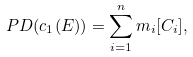<formula> <loc_0><loc_0><loc_500><loc_500>P D ( c _ { 1 } ( E ) ) = \sum _ { i = 1 } ^ { n } m _ { i } [ C _ { i } ] ,</formula> 